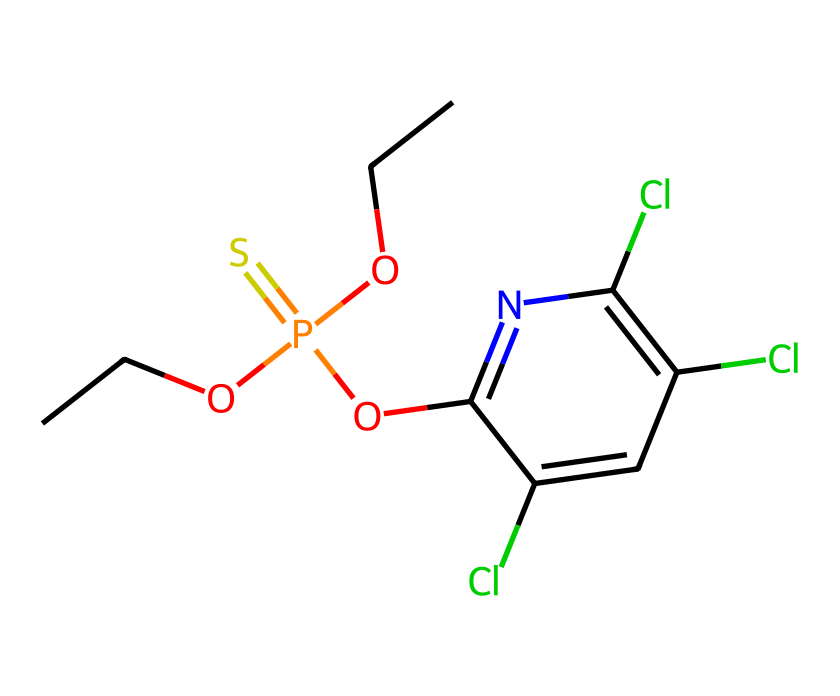How many chlorine atoms are present in the structure? The SMILES representation indicates three occurrences of the element chlorine, represented by "Cl". Each "Cl" indicates a chlorine atom in the chemical structure, so counting them gives three.
Answer: 3 What is the primary functional group in chlorpyrifos? By analyzing the SMILES representation, we see the presence of a phosphorus atom bonded to a sulfur and oxygen, which indicates it is a phosphate group, specifically a thiophosphate here due to the sulfur substitution.
Answer: phosphate What is the total number of carbon atoms in chlorpyrifos? The SMILES notation shows several "C" atoms, and upon counting, there are 8 carbon atoms in total in the structure, which contribute to the hydrocarbon base of the pesticide molecule.
Answer: 8 Which atoms in the structure suggest it is a pesticide? The presence of the phosphorus atom, in combination with multiple halogen atoms (specifically chlorine), signifies that this compound contains elements typical in organophosphate pesticides, which act as nerve agents or insecticides.
Answer: phosphorus Is the molecular structure of chlorpyrifos symmetrical? The arrangement of the atoms reveals that chlorpyrifos has asymmetrical features due to the arrangement of the chlorine atoms and the orientation of the alkoxy groups attached to phosphorus, leading to a lack of symmetry.
Answer: no What type of atom is mostly associated with organophosphate pesticides like chlorpyrifos? Organophosphate pesticides usually contain phosphorus atoms, which are central to their mechanism of action, and their structure often features a phosphorus atom bonded to various groups, making it distinct in pesticide chemistry.
Answer: phosphorus 